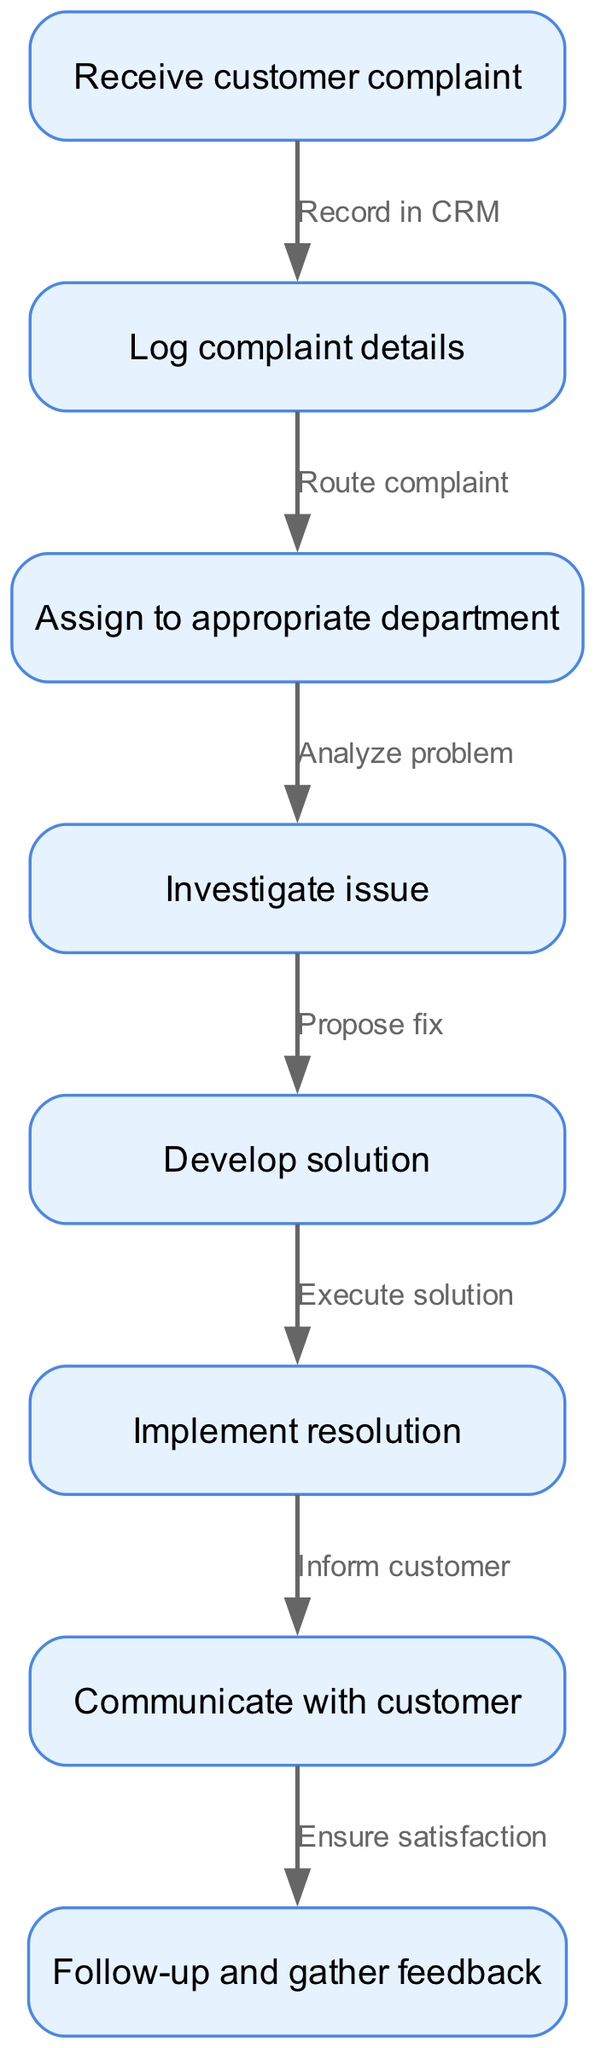What's the first step in the customer complaint resolution process? The first step is to "Receive customer complaint." This is the starting point of the flow chart, as indicated by the initial node without any incoming edges.
Answer: Receive customer complaint How many nodes are there in the diagram? The diagram contains 8 nodes, which represent different steps in the customer complaint resolution process. Each node corresponds to a specific action that needs to be taken.
Answer: 8 What is the action taken after logging the complaint details? After logging the complaint details, the next action is to "Assign to appropriate department." This follows directly by analyzing the edge from node 2 to node 3.
Answer: Assign to appropriate department What step follows the implementation of the resolution? The step that follows the implementation of the resolution is "Communicate with customer." This is derived from the flow where node 6 directs to node 7.
Answer: Communicate with customer Which two steps are directly connected by an edge that indicates a feedback process? The steps connected are "Communicate with customer" and "Follow-up and gather feedback." This connection emphasizes the importance of ensuring customer satisfaction after the resolution.
Answer: Communicate with customer and Follow-up and gather feedback What is the purpose of the edge labeled "Route complaint"? The "Route complaint" edge connects the logging of complaint details to the assignment to the appropriate department. It signifies the action of directing the logged complaints to the specific department that can handle them.
Answer: Route complaint What is the last step in the complaint resolution process? The last step in the process is "Follow-up and gather feedback." This is the final node and indicates the closure of the resolution process by ensuring customer satisfaction and collecting any insights.
Answer: Follow-up and gather feedback How many edges are in the diagram? The diagram consists of 7 edges, which represent the connections or transitions between the different steps in the complaint resolution process. Each edge defines a specific action that occurs between two nodes.
Answer: 7 What is the relationship between "Investigate issue" and "Develop solution"? The relationship is that "Investigate issue" leads to "Develop solution," implying that an investigation is necessary to propose an effective solution to the customer's complaint.
Answer: Investigate issue leads to Develop solution Which node follows "Assign to appropriate department"? The node that follows "Assign to appropriate department" is "Investigate issue," which is indicated by the edge that connects node 3 to node 4 in the diagram.
Answer: Investigate issue 